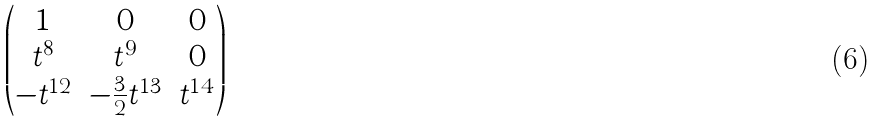Convert formula to latex. <formula><loc_0><loc_0><loc_500><loc_500>\begin{pmatrix} 1 & 0 & 0 \\ t ^ { 8 } & t ^ { 9 } & 0 \\ - t ^ { 1 2 } & - \frac { 3 } { 2 } t ^ { 1 3 } & t ^ { 1 4 } \end{pmatrix}</formula> 